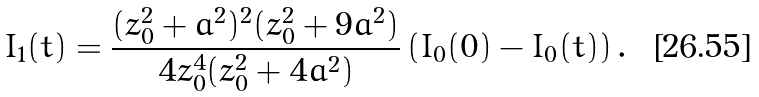Convert formula to latex. <formula><loc_0><loc_0><loc_500><loc_500>I _ { 1 } ( t ) = \frac { ( z _ { 0 } ^ { 2 } + a ^ { 2 } ) ^ { 2 } ( z _ { 0 } ^ { 2 } + 9 a ^ { 2 } ) } { 4 z _ { 0 } ^ { 4 } ( z _ { 0 } ^ { 2 } + 4 a ^ { 2 } ) } \left ( I _ { 0 } ( 0 ) - I _ { 0 } ( t ) \right ) .</formula> 